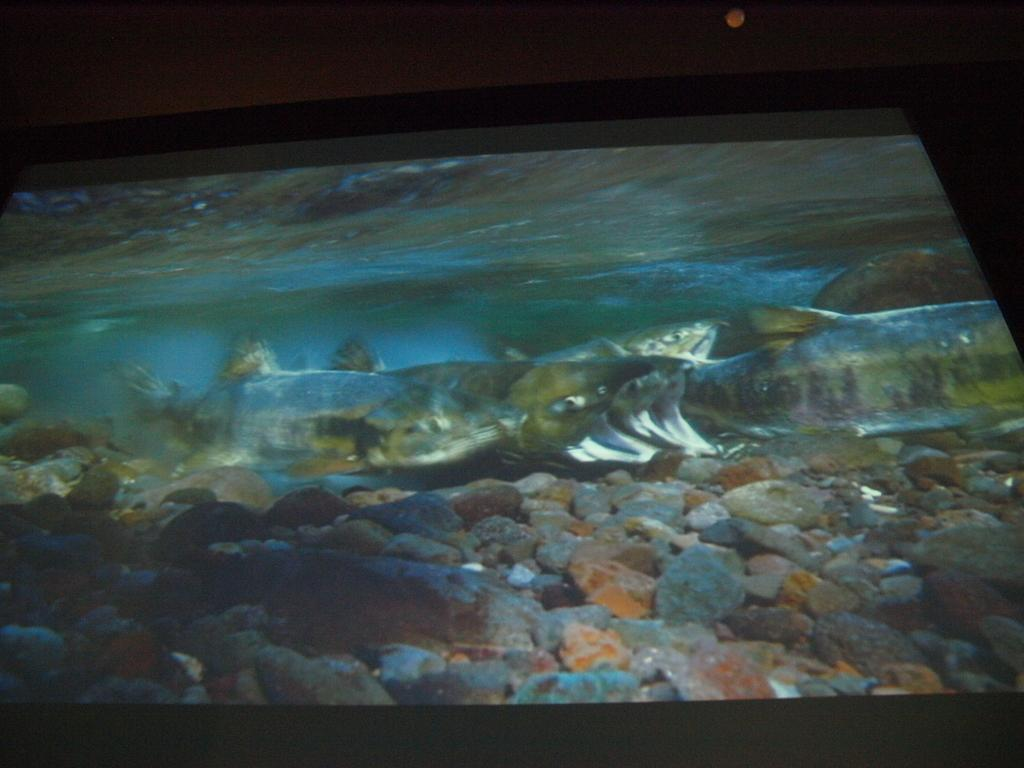What is the main object in the image? There is an object that looks like an aquarium in the image. What can be seen inside the aquarium? There are fish inside the aquarium. What is the aquarium filled with? There is water inside the aquarium. Are there any decorative elements inside the aquarium? Yes, there are stones inside the aquarium. Where are the scissors located in the image? There are no scissors present in the image. What type of rock is visible in the image? There is no rock visible in the image; only an aquarium with fish, water, and stones is present. 